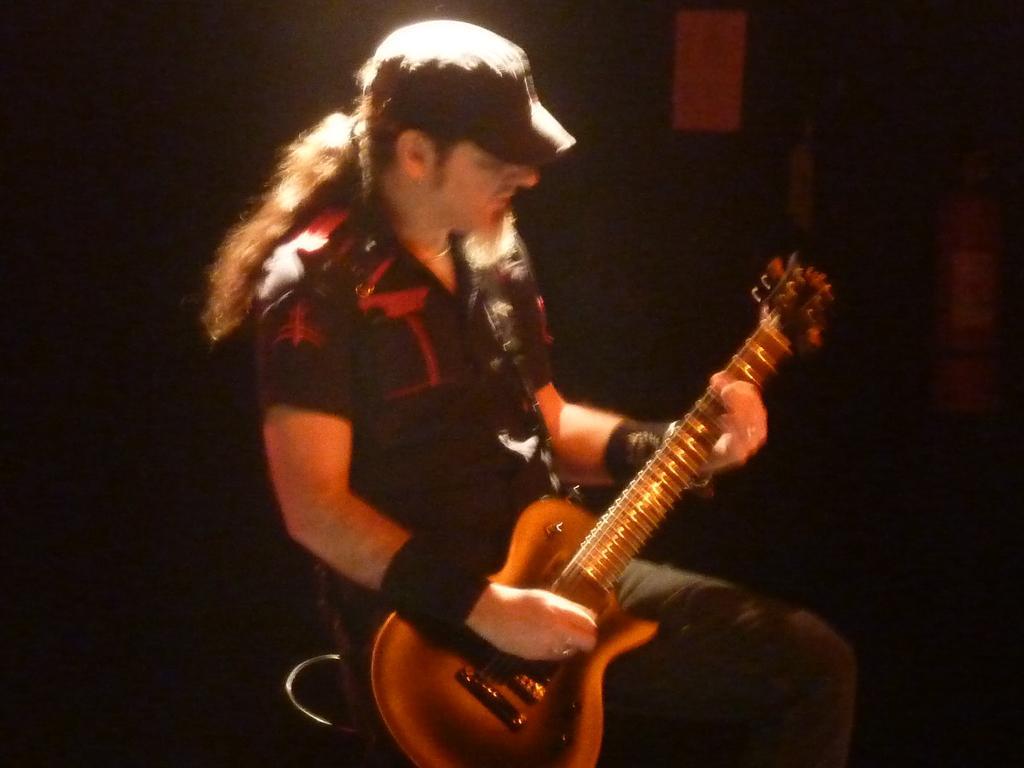Can you describe this image briefly? There is one man standing and holding a guitar in the middle of this image. It is dark in the background. 